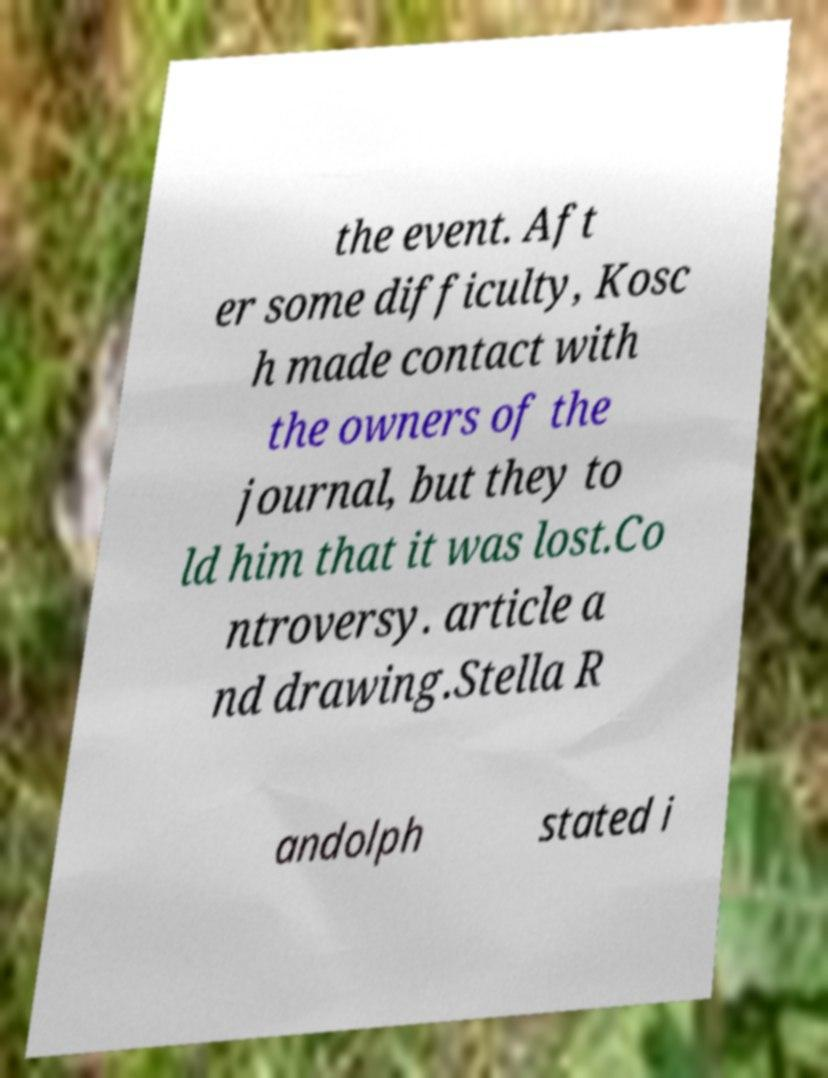Can you read and provide the text displayed in the image?This photo seems to have some interesting text. Can you extract and type it out for me? the event. Aft er some difficulty, Kosc h made contact with the owners of the journal, but they to ld him that it was lost.Co ntroversy. article a nd drawing.Stella R andolph stated i 